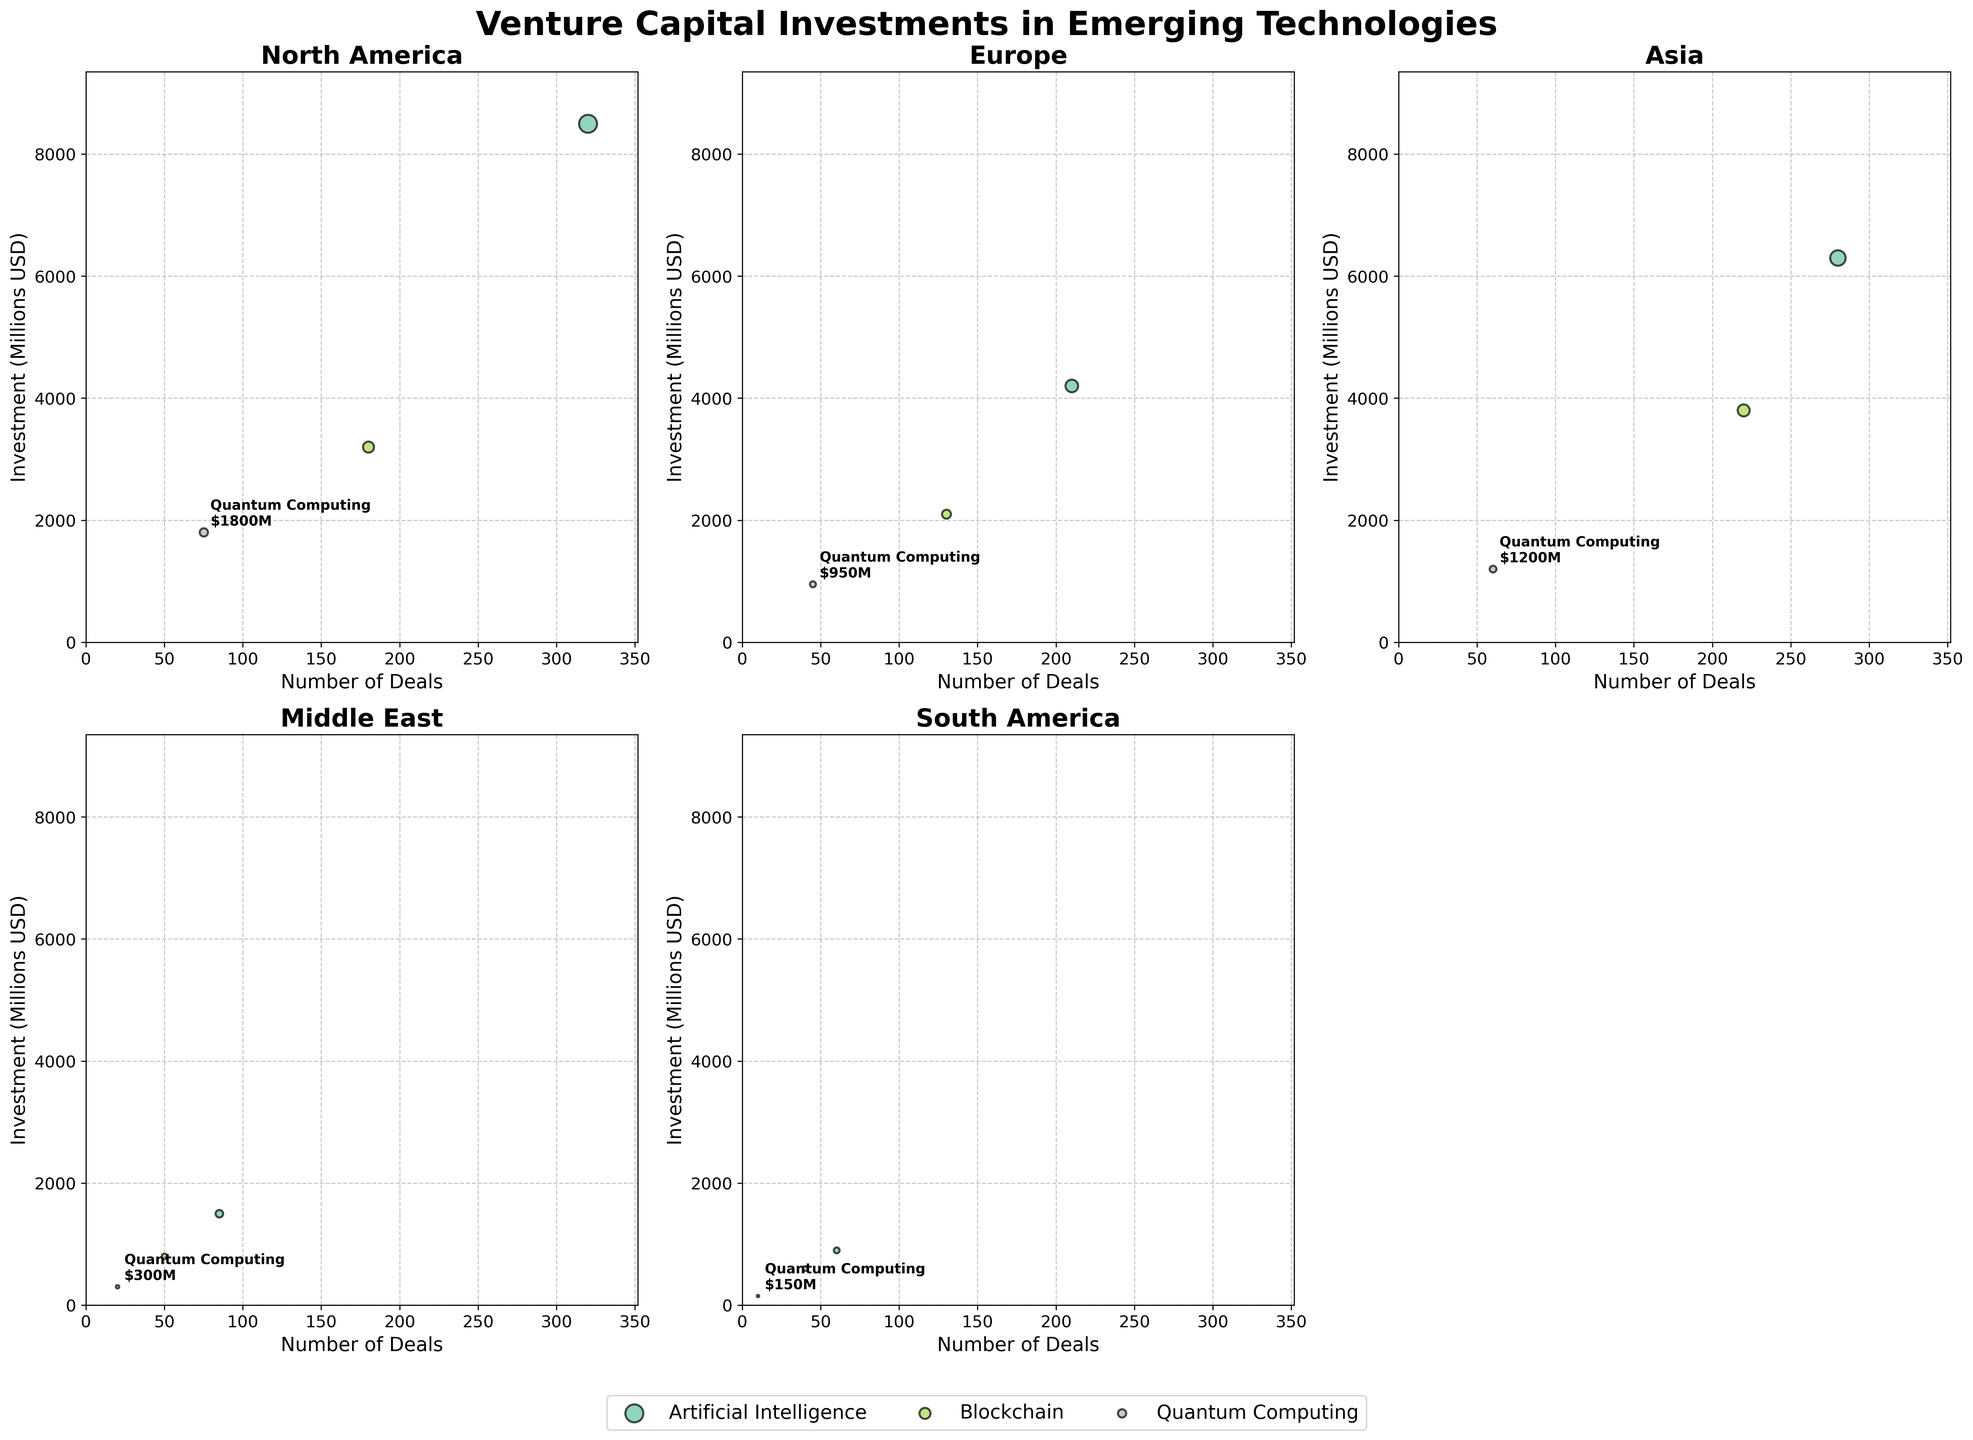What region has the highest investment in Artificial Intelligence? To find the region with the highest investment in Artificial Intelligence, look at the y-axis values in each subplot for the points labeled as Artificial Intelligence. The region with the highest value on the y-axis is the answer.
Answer: North America Which technology in Europe received the lowest investment? In the Europe subplot, identify the points for each technology and their corresponding y-axis values. The technology with the lowest y-axis value is the answer.
Answer: Quantum Computing What is the total number of deals in Artificial Intelligence investments across all regions? Add the number of deals for Artificial Intelligence from each region: 320 (North America) + 210 (Europe) + 280 (Asia) + 85 (Middle East) + 60 (South America). Sum these numbers to get the total.
Answer: 955 Compare the investment in Blockchain in Asia with that in North America. Which is greater and by how much? Look at the y-axis values for Blockchain in both Asia and North America subplots. Subtract the investment value of North America from that of Asia.
Answer: Asia by $600 million Which region, out of those displayed, has the fewest number of total deals for all technologies? For each region subplot, add the number of deals for all technologies. The region with the smallest sum is the answer. Middle East: 85 + 50 + 20 = 155. South America: 60 + 40 + 10 = 110. Compare these numbers to find the answer.
Answer: South America What is the average investment amount (in millions USD) in Quantum Computing across all regions? Sum the investment amounts for Quantum Computing in each region and then divide by the number of regions: (1800 + 950 + 1200 + 300 + 150) / 5 = 4400 / 5 = 880.
Answer: 880 How does the number of deals in Blockchain compare between North America and Europe? Look at the x-axis values for Blockchain in North America and Europe subplots. Compare these values to determine the relationship.
Answer: North America has more deals Which technology received the most consistent level of investment across all regions? For each technology, compare the spread of investment amounts (y-axis values) across all regions' subplots. The technology with the smallest range (difference between highest and lowest investments) is the answer.
Answer: Artificial Intelligence 